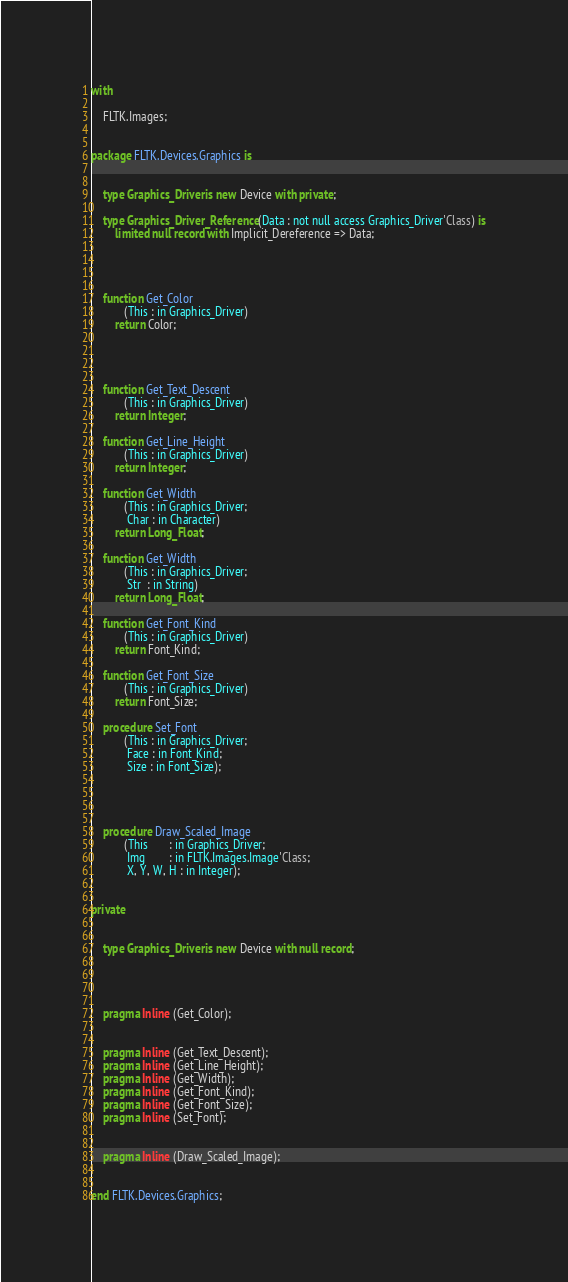Convert code to text. <code><loc_0><loc_0><loc_500><loc_500><_Ada_>

with

    FLTK.Images;


package FLTK.Devices.Graphics is


    type Graphics_Driver is new Device with private;

    type Graphics_Driver_Reference (Data : not null access Graphics_Driver'Class) is
        limited null record with Implicit_Dereference => Data;




    function Get_Color
           (This : in Graphics_Driver)
        return Color;




    function Get_Text_Descent
           (This : in Graphics_Driver)
        return Integer;

    function Get_Line_Height
           (This : in Graphics_Driver)
        return Integer;

    function Get_Width
           (This : in Graphics_Driver;
            Char : in Character)
        return Long_Float;

    function Get_Width
           (This : in Graphics_Driver;
            Str  : in String)
        return Long_Float;

    function Get_Font_Kind
           (This : in Graphics_Driver)
        return Font_Kind;

    function Get_Font_Size
           (This : in Graphics_Driver)
        return Font_Size;

    procedure Set_Font
           (This : in Graphics_Driver;
            Face : in Font_Kind;
            Size : in Font_Size);




    procedure Draw_Scaled_Image
           (This       : in Graphics_Driver;
            Img        : in FLTK.Images.Image'Class;
            X, Y, W, H : in Integer);


private


    type Graphics_Driver is new Device with null record;




    pragma Inline (Get_Color);


    pragma Inline (Get_Text_Descent);
    pragma Inline (Get_Line_Height);
    pragma Inline (Get_Width);
    pragma Inline (Get_Font_Kind);
    pragma Inline (Get_Font_Size);
    pragma Inline (Set_Font);


    pragma Inline (Draw_Scaled_Image);


end FLTK.Devices.Graphics;

</code> 